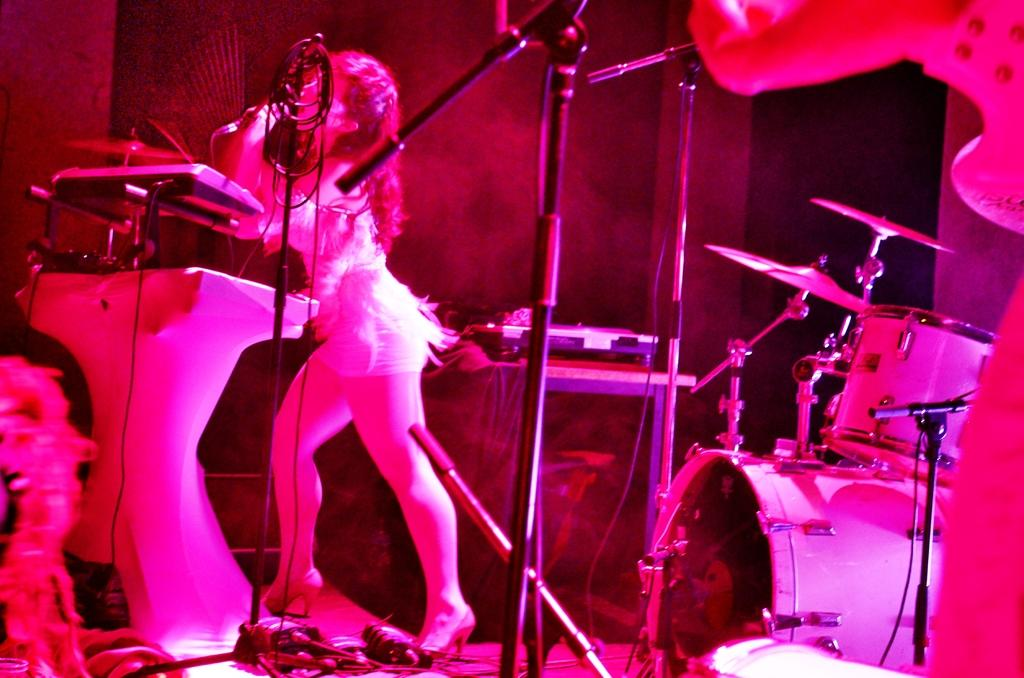Who is present in the image? There is a woman in the image. What can be seen in the image besides the woman? There are stands, musical instruments, devices, and objects in the image. What type of objects are present in the image? The objects in the image are musical instruments and devices. What is visible in the background of the image? There is a wall in the background of the image. What type of leaf is being used as a game prop in the image? There is no leaf or game present in the image. Where is the basin located in the image? There is no basin present in the image. 